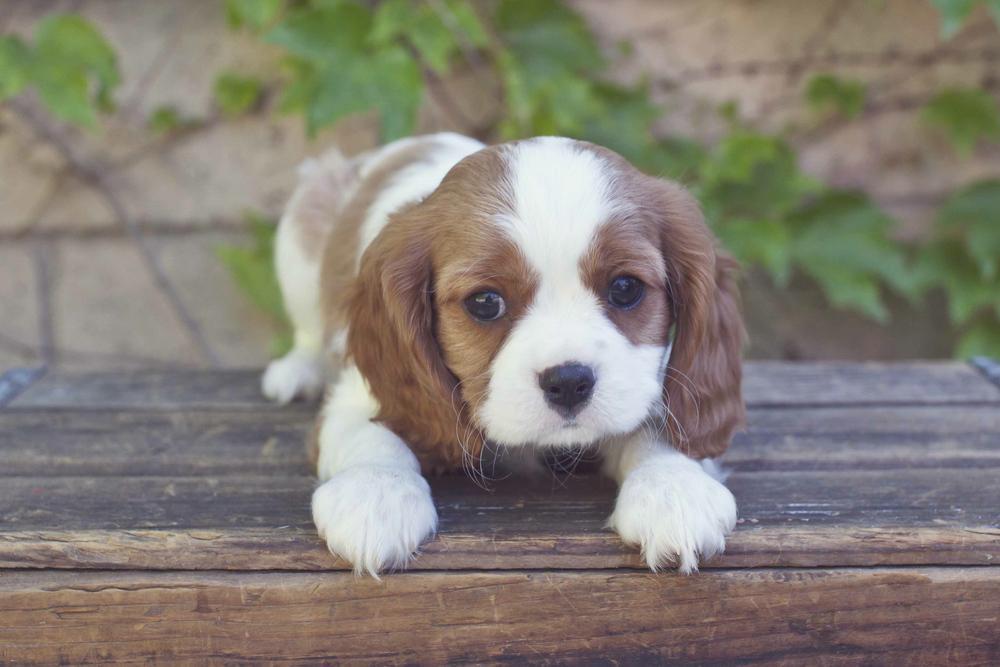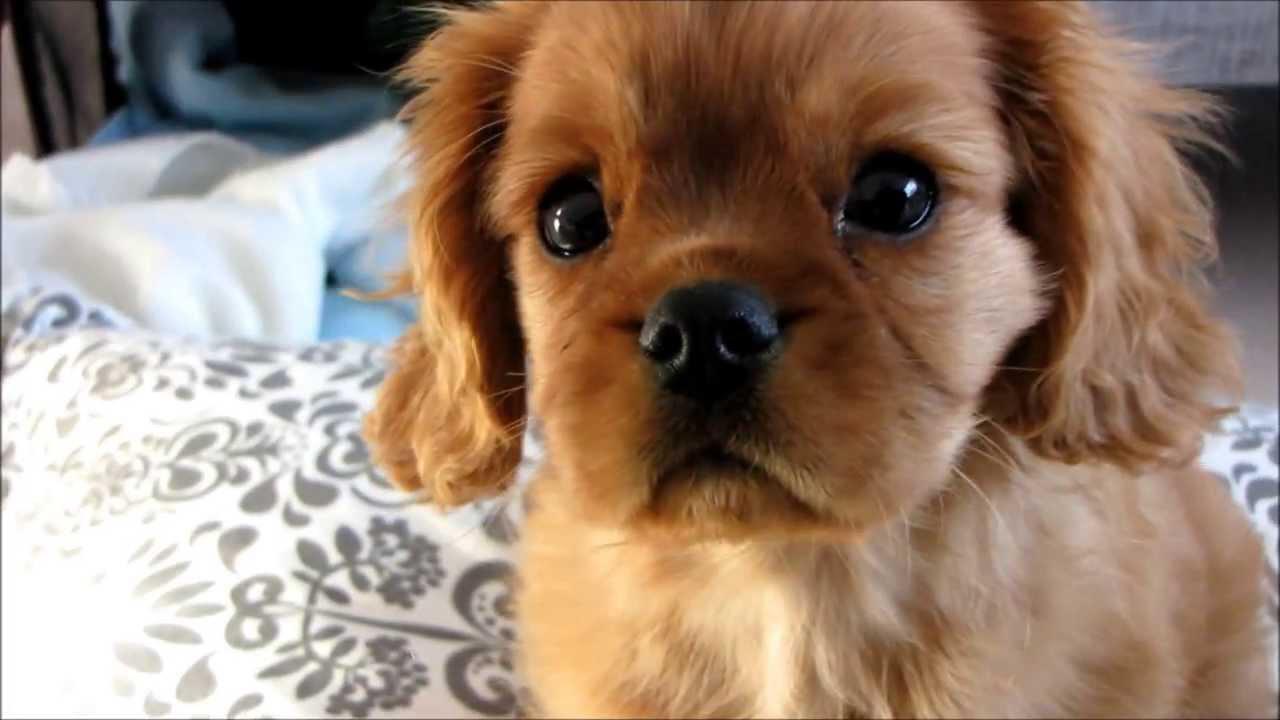The first image is the image on the left, the second image is the image on the right. For the images shown, is this caption "A spaniel puppy is posed on its belly on wood planks, in one image." true? Answer yes or no. Yes. 